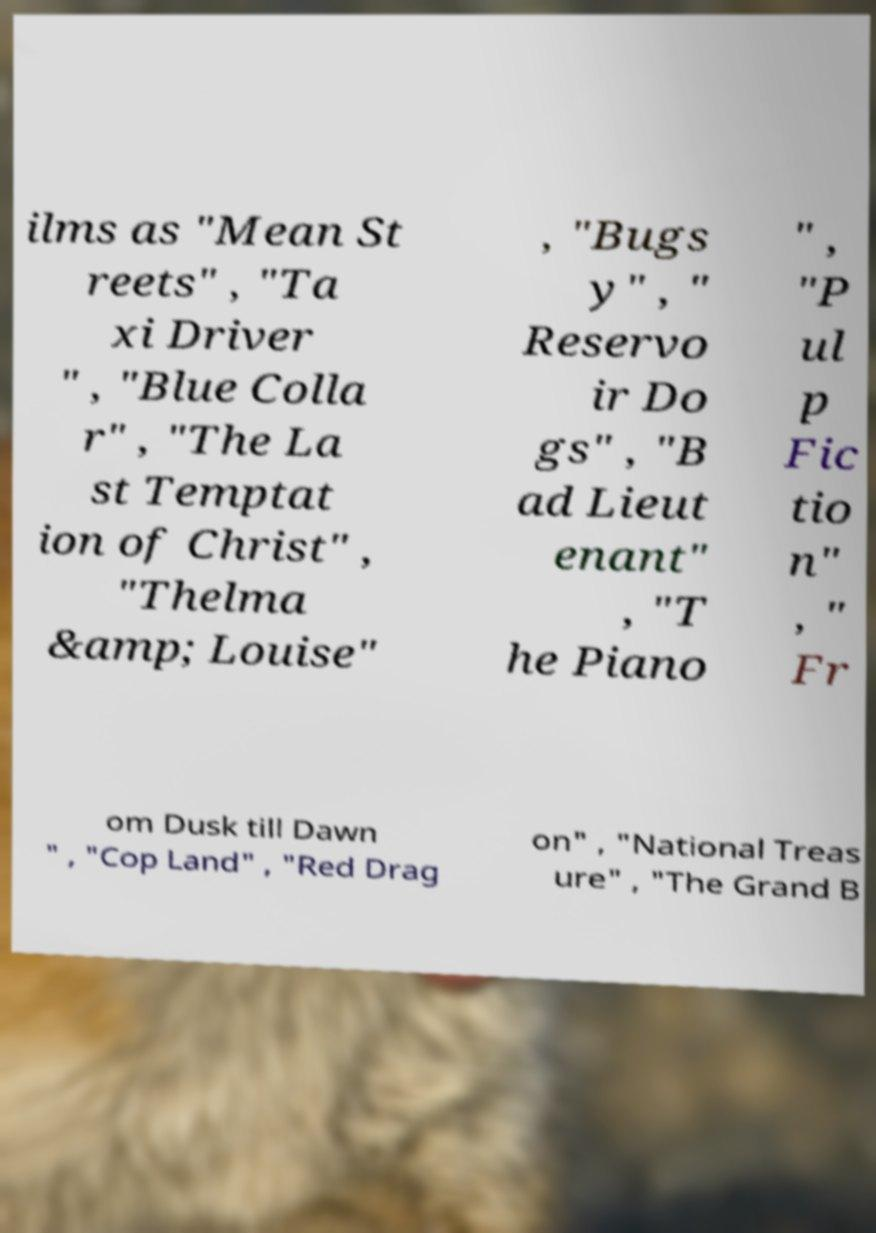What messages or text are displayed in this image? I need them in a readable, typed format. ilms as "Mean St reets" , "Ta xi Driver " , "Blue Colla r" , "The La st Temptat ion of Christ" , "Thelma &amp; Louise" , "Bugs y" , " Reservo ir Do gs" , "B ad Lieut enant" , "T he Piano " , "P ul p Fic tio n" , " Fr om Dusk till Dawn " , "Cop Land" , "Red Drag on" , "National Treas ure" , "The Grand B 